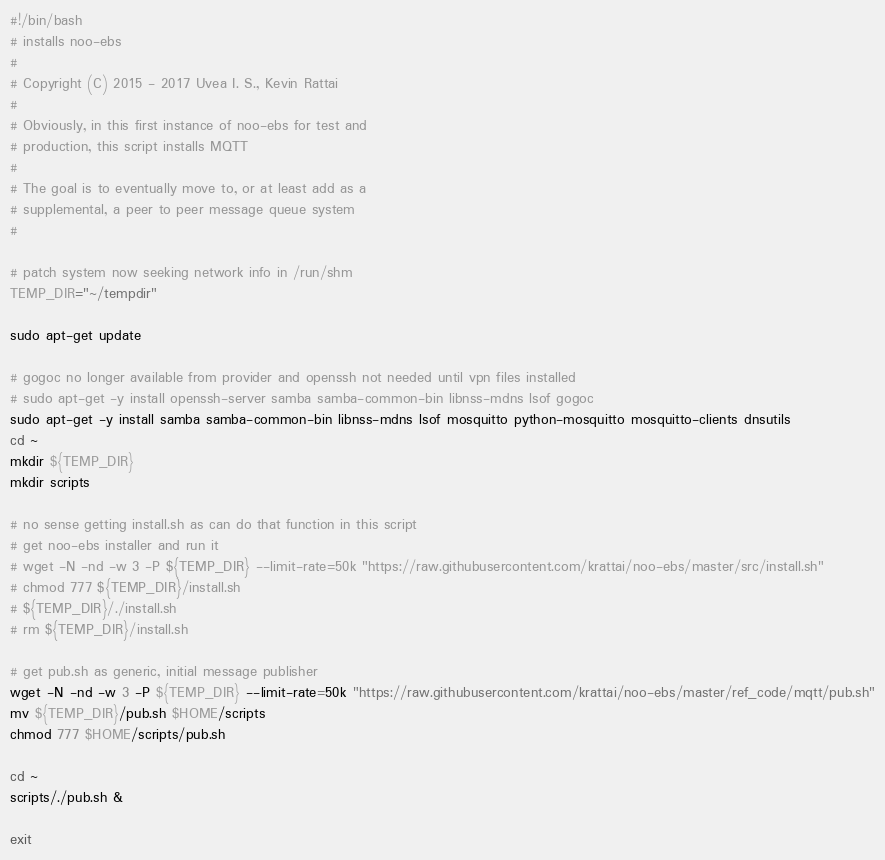<code> <loc_0><loc_0><loc_500><loc_500><_Bash_>#!/bin/bash
# installs noo-ebs
#
# Copyright (C) 2015 - 2017 Uvea I. S., Kevin Rattai
#
# Obviously, in this first instance of noo-ebs for test and
# production, this script installs MQTT
#
# The goal is to eventually move to, or at least add as a
# supplemental, a peer to peer message queue system
#

# patch system now seeking network info in /run/shm
TEMP_DIR="~/tempdir"

sudo apt-get update

# gogoc no longer available from provider and openssh not needed until vpn files installed
# sudo apt-get -y install openssh-server samba samba-common-bin libnss-mdns lsof gogoc
sudo apt-get -y install samba samba-common-bin libnss-mdns lsof mosquitto python-mosquitto mosquitto-clients dnsutils
cd ~
mkdir ${TEMP_DIR}
mkdir scripts

# no sense getting install.sh as can do that function in this script
# get noo-ebs installer and run it
# wget -N -nd -w 3 -P ${TEMP_DIR} --limit-rate=50k "https://raw.githubusercontent.com/krattai/noo-ebs/master/src/install.sh"
# chmod 777 ${TEMP_DIR}/install.sh
# ${TEMP_DIR}/./install.sh
# rm ${TEMP_DIR}/install.sh

# get pub.sh as generic, initial message publisher
wget -N -nd -w 3 -P ${TEMP_DIR} --limit-rate=50k "https://raw.githubusercontent.com/krattai/noo-ebs/master/ref_code/mqtt/pub.sh"
mv ${TEMP_DIR}/pub.sh $HOME/scripts
chmod 777 $HOME/scripts/pub.sh

cd ~
scripts/./pub.sh &

exit
</code> 